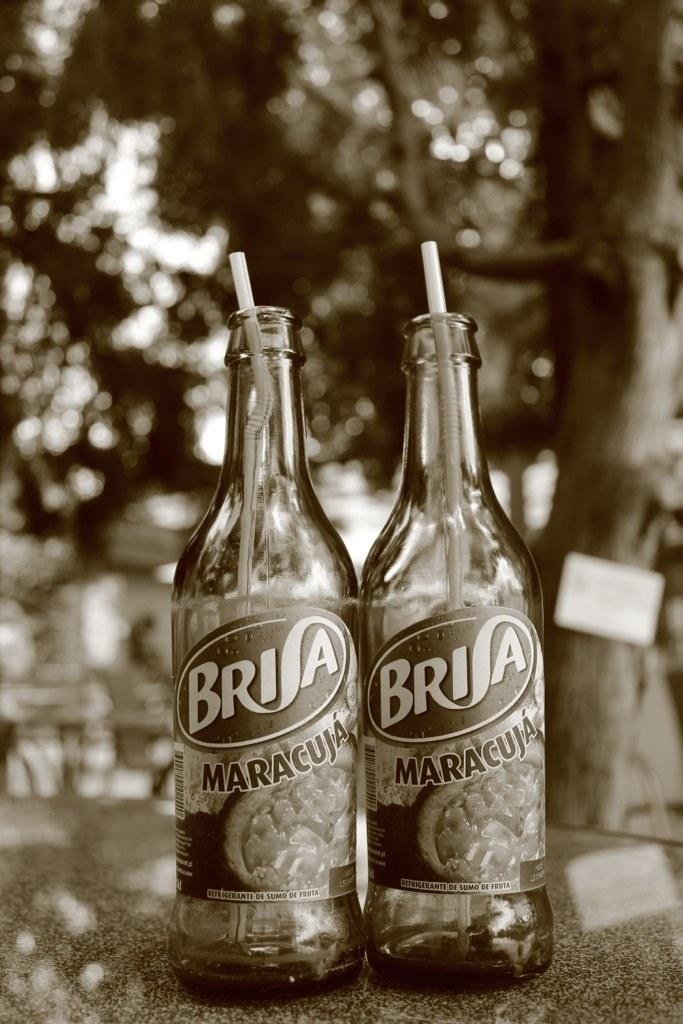How many bottles are visible in the image? There are two bottles in the image. What feature do the bottles have? The bottles have straws. What can be seen in the background of the image? There are trees in the background of the image. What type of guide is present in the image to help navigate the wealth? There is no guide or mention of wealth in the image; it only features two bottles with straws and trees in the background. 